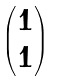Convert formula to latex. <formula><loc_0><loc_0><loc_500><loc_500>\begin{pmatrix} 1 \\ 1 \end{pmatrix}</formula> 